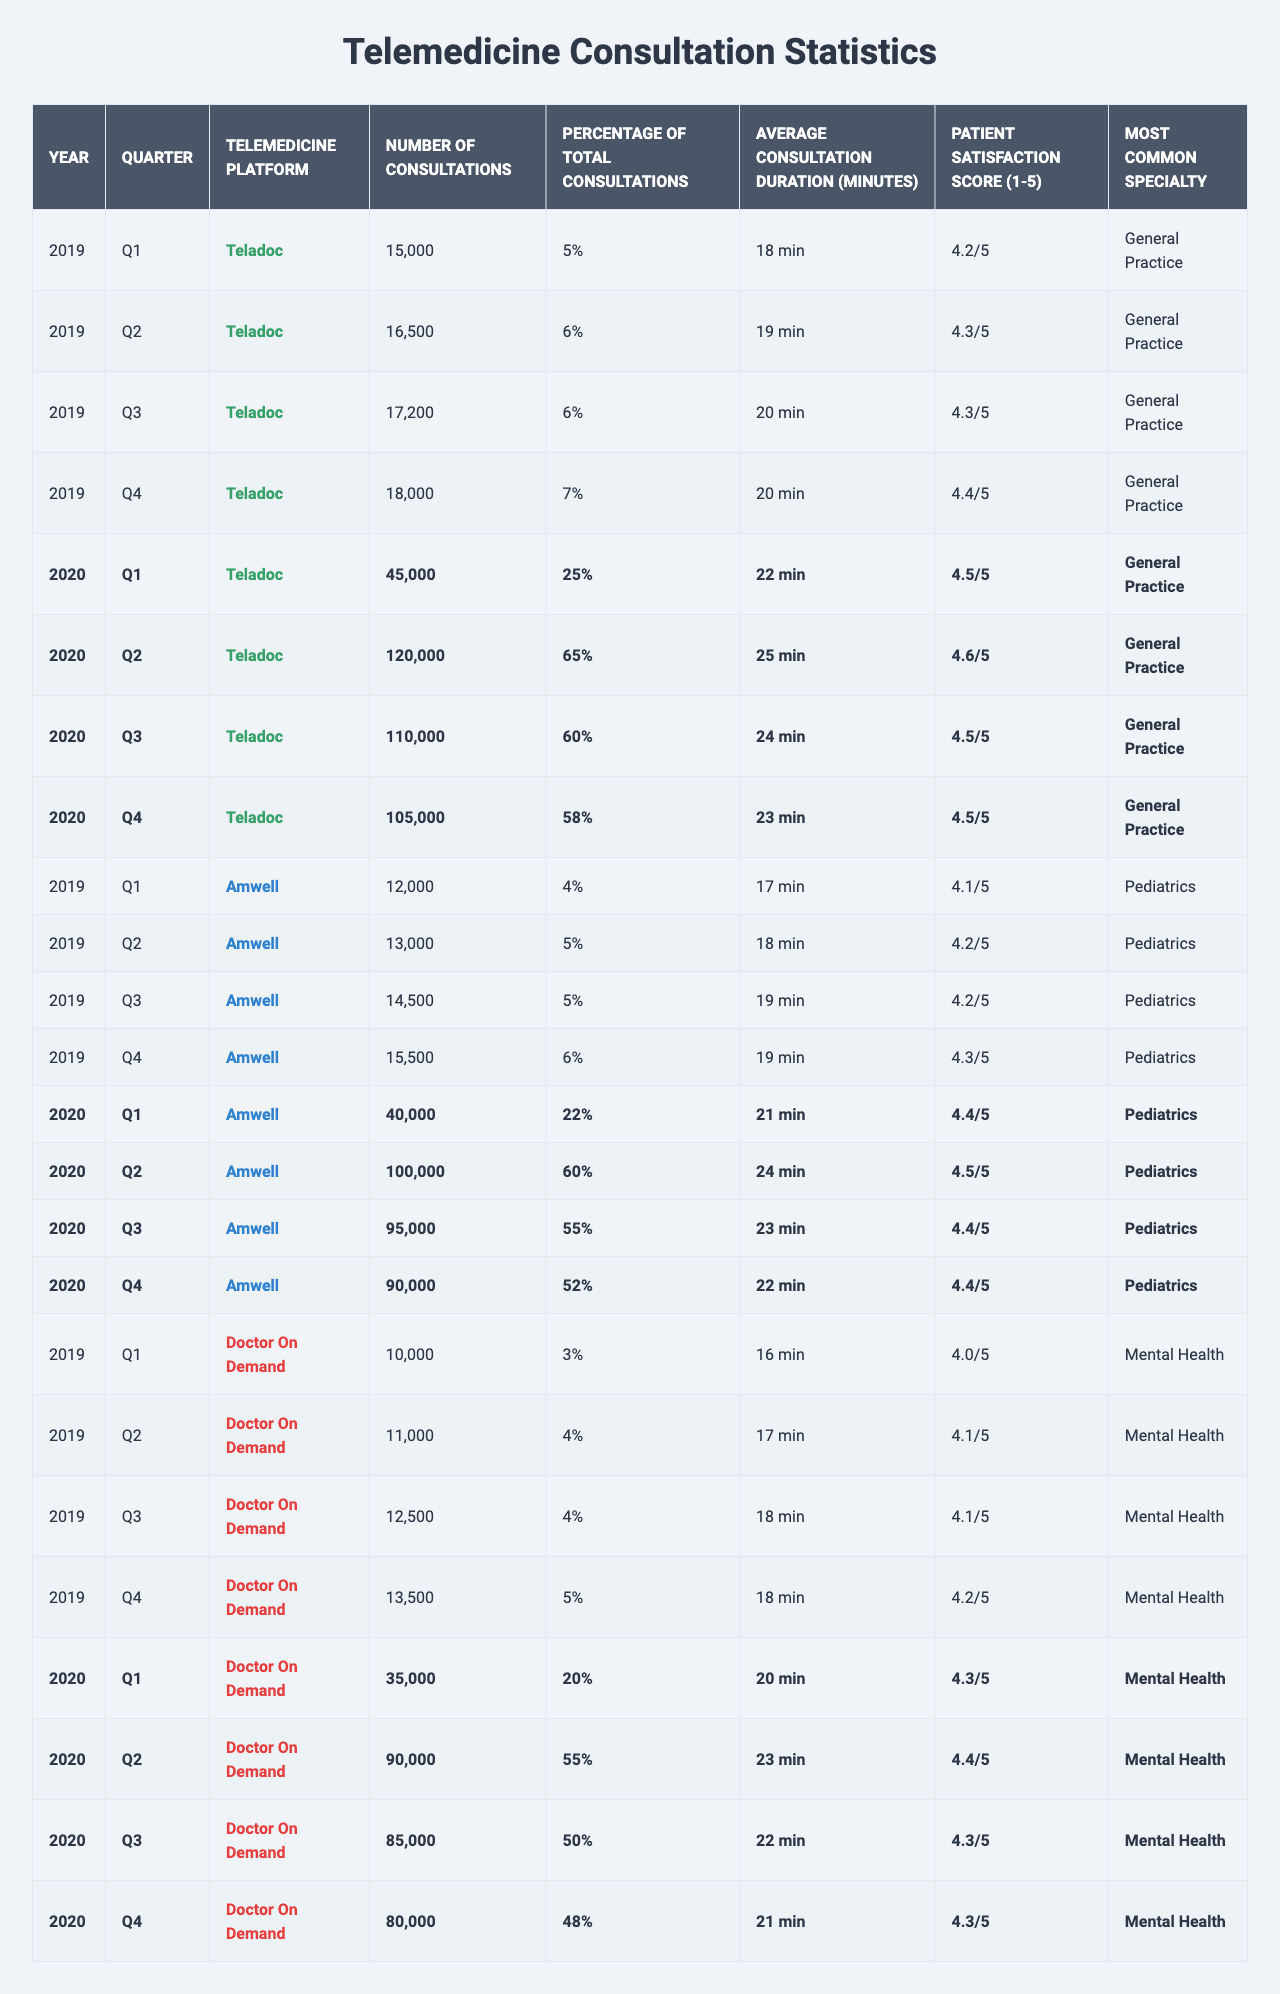What was the total number of consultations for Teladoc in 2020? In 2020, the number of consultations for Teladoc were: Q1: 45,000; Q2: 120,000; Q3: 110,000; Q4: 105,000. Adding these numbers gives 45,000 + 120,000 + 110,000 + 105,000 = 380,000.
Answer: 380,000 What is the average patient satisfaction score for Amwell during the pandemic? The patient satisfaction scores for Amwell in 2020 were: Q1: 4.4; Q2: 4.5; Q3: 4.4; Q4: 4.4. To find the average, sum these scores (4.4 + 4.5 + 4.4 + 4.4 = 17.7) and divide by the number of quarters (17.7/4 = 4.425).
Answer: 4.43 Which telemedicine platform had the highest percentage of total consultations in Q2 of 2020? In Q2 of 2020, the percentages were: Teladoc: 65%; Amwell: 60%; Doctor On Demand: 55%. Therefore, Teladoc had the highest percentage at 65%.
Answer: Teladoc Did the average consultation duration increase or decrease from 2019 to 2020 for Doctor On Demand? In 2019, the average durations for Doctor On Demand were: Q1: 16 mins; Q2: 17 mins; Q3: 18 mins; Q4: 18 mins (average = 17.25 mins). In 2020, they were: Q1: 20 mins; Q2: 23 mins; Q3: 22 mins; Q4: 21 mins (average = 21.5 mins). Thus, it increased from 17.25 mins to 21.5 mins.
Answer: Increased What was the greatest number of consultations recorded for any platform during the pandemic in 2020? The highest number of consultations in 2020 were for Amwell in Q2 with 100,000 consultations.
Answer: 100,000 Which specialty had the highest patient satisfaction score in the areas listed for 2020? For 2020, the patient satisfaction scores by specialty were: General Practice: 4.5; Pediatrics: 4.4; Mental Health: 4.3. Therefore, General Practice had the highest score at 4.5.
Answer: General Practice How did the total number of consultations for Amwell change from Q1 to Q4 in 2020? Amwell consultations were: Q1: 40,000, Q4: 90,000. The change is 90,000 - 40,000 = 50,000 more consultations in Q4.
Answer: Increased by 50,000 Was the average consultation duration for Telemedicine platforms higher in 2020 compared to 2019? In 2019, the average durations for Teladoc, Amwell, and Doctor On Demand were 18.5 mins, 18.25 mins, and 17.25 mins respectively, averaging 18 mins across all platforms. In 2020, the averages were 23.5 mins for Teladoc, 23 mins for Amwell, and 21.5 mins for Doctor On Demand, averaging 22.33 mins. Thus, the average increased.
Answer: Yes What is the trend in patient satisfaction scores for Telemedicine platforms across all quarters of 2020? Reviewing the scores: Teladoc scores were 4.5, 4.6, 4.5, 4.5. Amwell scores remained steady at 4.4 and 4.5. Doctor On Demand scores fluctuated from 4.3 to 4.3. Overall, the scores indicated stability with a slight improvement in mid-year for some platforms.
Answer: Stable with slight improvements 